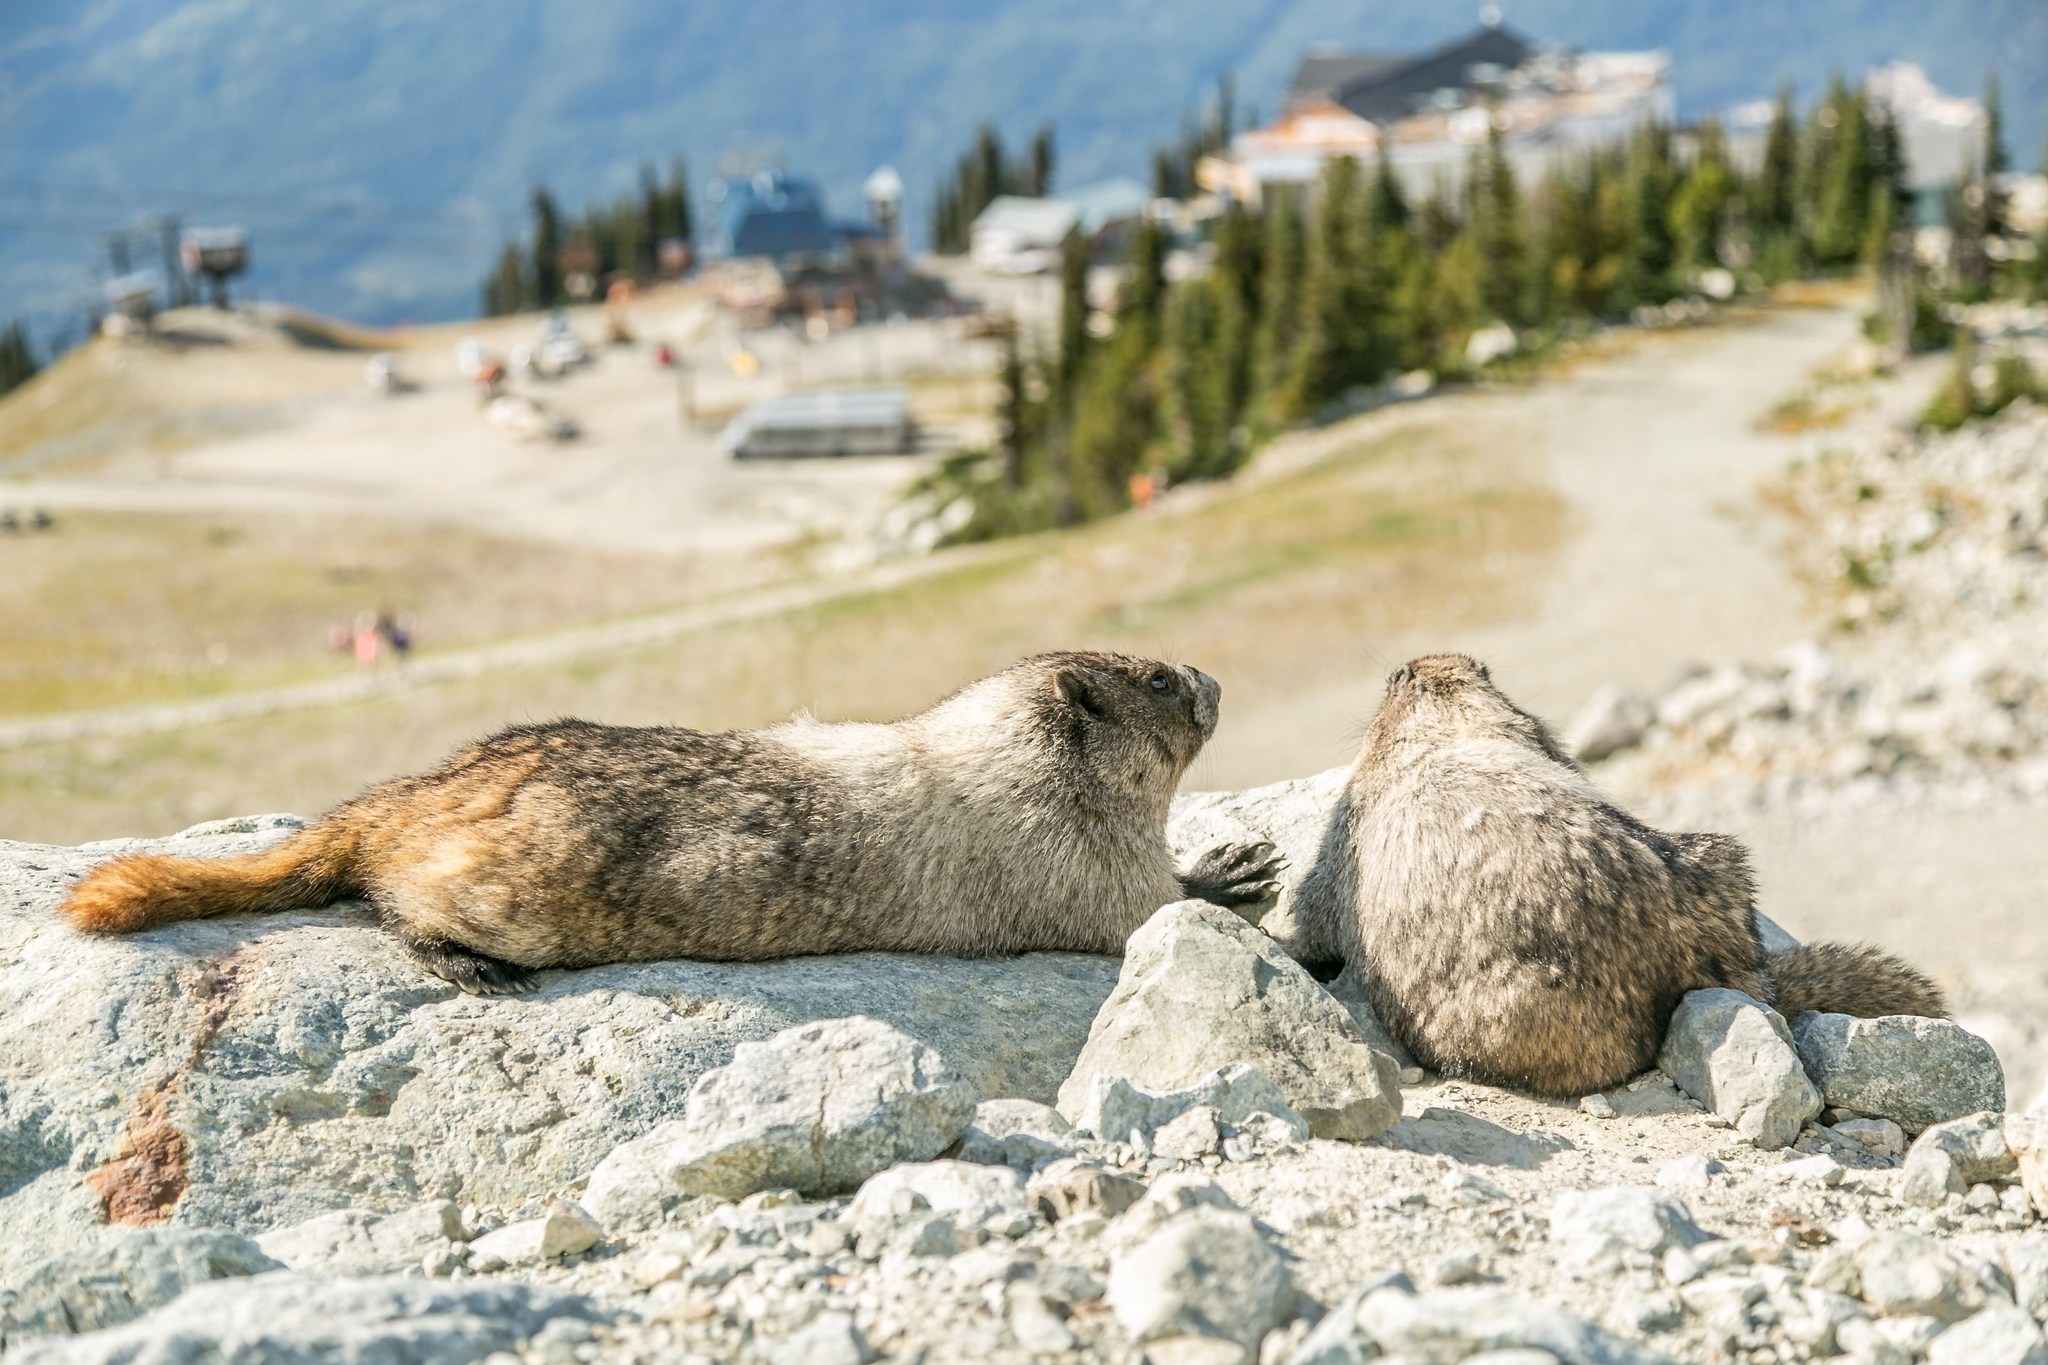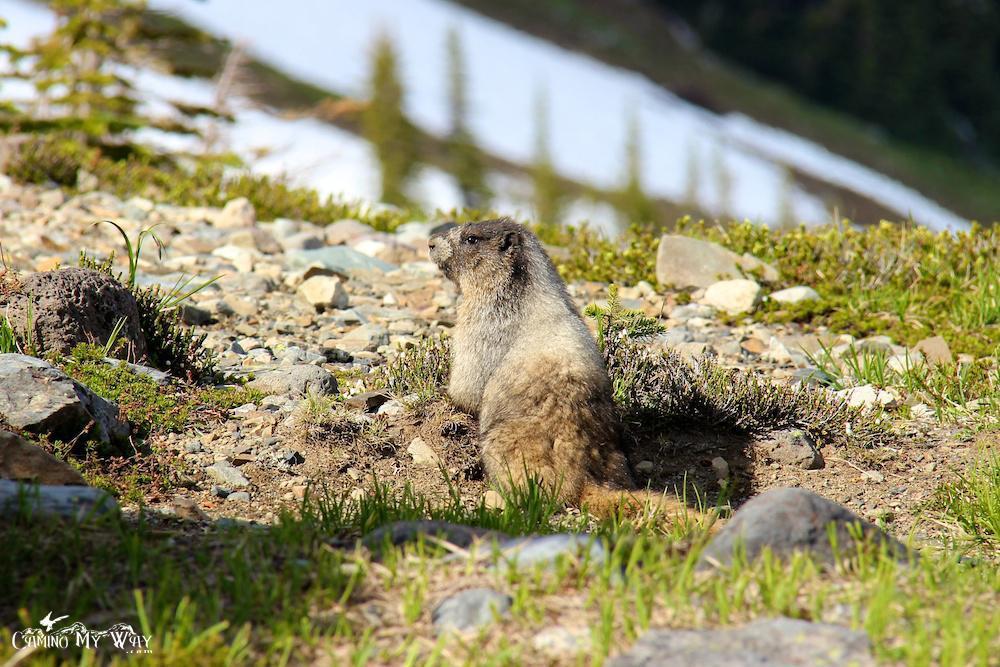The first image is the image on the left, the second image is the image on the right. Analyze the images presented: Is the assertion "There are two ground hogs perched high on a rock." valid? Answer yes or no. Yes. The first image is the image on the left, the second image is the image on the right. Examine the images to the left and right. Is the description "One of the groundhogs is near yellow flowers." accurate? Answer yes or no. No. 